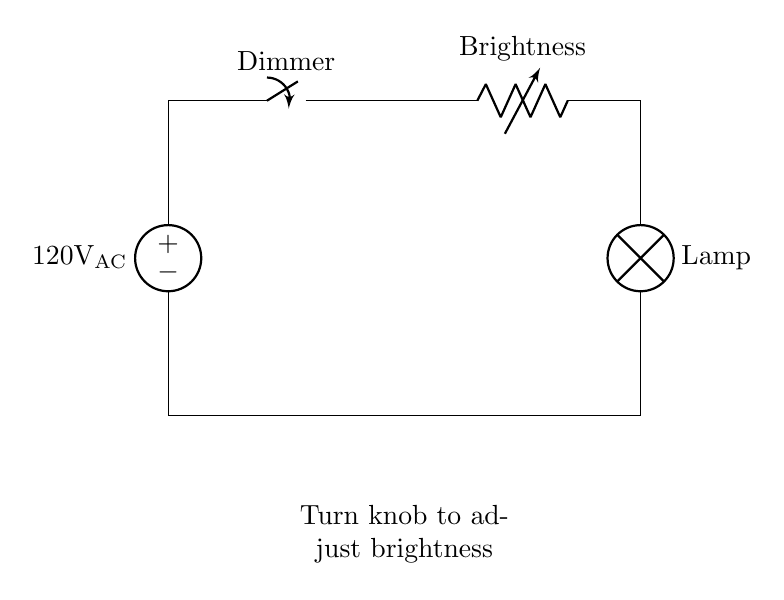What is the power source voltage in this circuit? The circuit shows a voltage source labeled as 120V AC. This indicates the amount of electrical energy supplied to the circuit.
Answer: 120 volts AC What component is used to adjust brightness? The component is labeled as a "Dimmer," which is a type of switch controlling the brightness of the lamp. It adjusts the amount of current flowing to the lamp.
Answer: Dimmer What is the role of the variable resistor in this circuit? The variable resistor, labeled "Brightness," allows for adjustments in the resistance, which changes the current flowing to the lamp and thus its brightness.
Answer: Adjusts brightness How does turning the knob affect the circuit? Turning the knob on the dimmer modifies the resistance in the circuit. This alters the current that reaches the lamp, allowing it to change brightness accordingly.
Answer: Changes brightness What device is represented at the end of the circuit? The device is labeled as "Lamp," which is the final component in the circuit receiving current and lighting up.
Answer: Lamp What happens when the circuit is closed? Once the circuit is closed, current can flow from the power source through the dimmer and variable resistor to the lamp, enabling it to light up.
Answer: Current flows What type of circuit is this? This is a household dimmer switch circuit, specifically designed to control the brightness of lighting fixtures in homes.
Answer: Dimmer switch circuit 